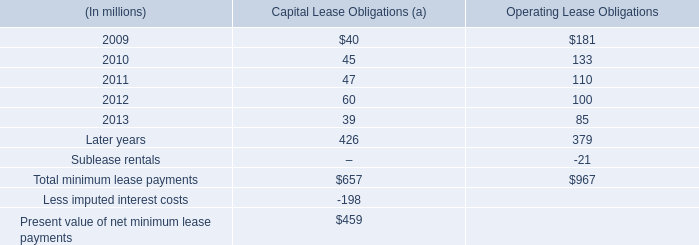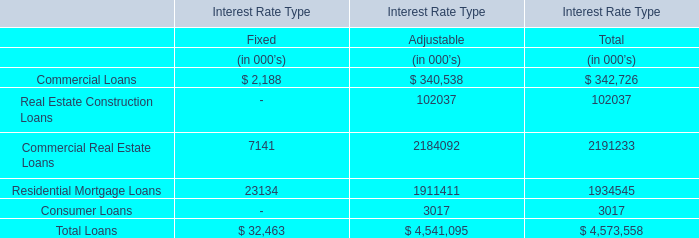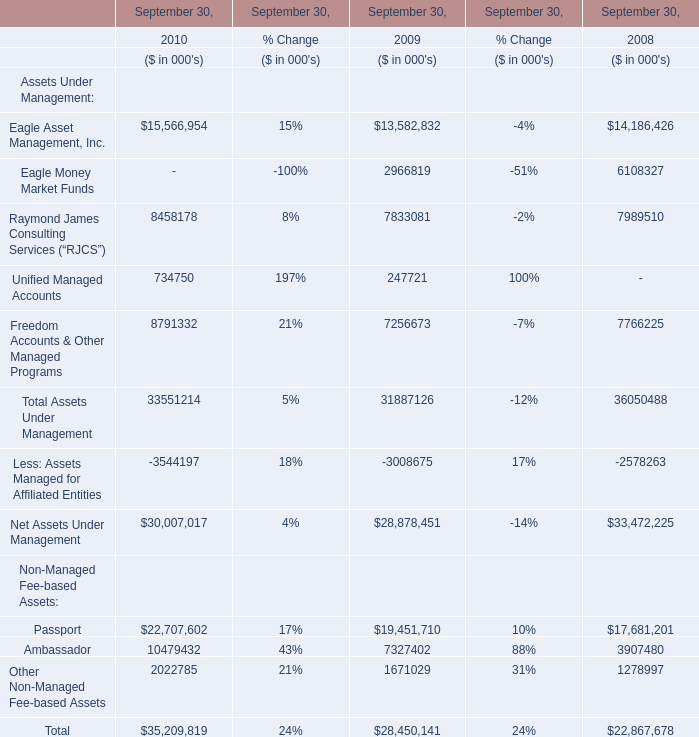How many Assets Under Managemen exceed the average of Assets Under Managemen in 2009? 
Answer: 4. 